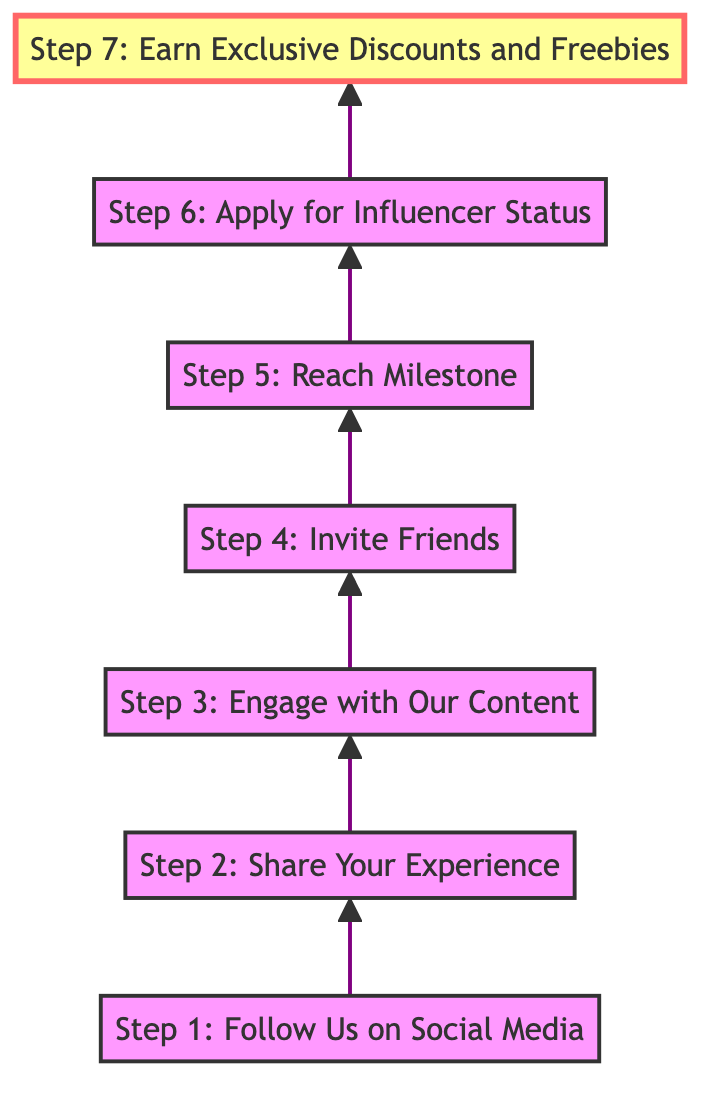What is the first step to becoming a top influencer? The first step in the flow chart is "Step 1: Follow Us on Social Media." This is the starting point, as indicated by its position at the bottom of the diagram.
Answer: Step 1: Follow Us on Social Media How many steps are there in total? By counting the individual steps listed in the diagram from the bottom to the top, including the final exclusive discounts and freebies, there are seven distinct steps.
Answer: 7 What is the relationship between Step 3 and Step 4? The flow chart shows that Step 3 ("Engage with Our Content") leads directly to Step 4 ("Invite Friends"). This means that after engaging, the next action is to invite friends.
Answer: Directly leads to What milestone must be reached in Step 5? According to Step 5 in the chart, the milestone that must be achieved is 500 likes, shares, or comments on posts featuring the products.
Answer: 500 likes, shares, or comments What happens after applying for influencer status in Step 6? The subsequent node after Step 6 ("Apply for Influencer Status") is Step 7 ("Earn Exclusive Discounts and Freebies"), indicating that applying leads directly to earning discounts and freebies if approved.
Answer: Earn Exclusive Discounts and Freebies Which step involves using a referral code? The step that mentions using a referral code is Step 4, which states, "Encourage your friends to follow and engage with our shop's social media by sharing your unique referral code."
Answer: Step 4: Invite Friends How does the flow direction of this diagram affect the process? The bottom-to-top flow direction illustrates the progression of steps from following on social media to ultimately earning exclusive benefits, suggesting that each step builds upon the previous one.
Answer: Builds upon previous steps What is the final outcome of completing all steps? The final outcome, which is highlighted in Step 7, is to earn exclusive discounts and freebies, showing the ultimate goal for influencers after completing all prior steps.
Answer: Earn Exclusive Discounts and Freebies 